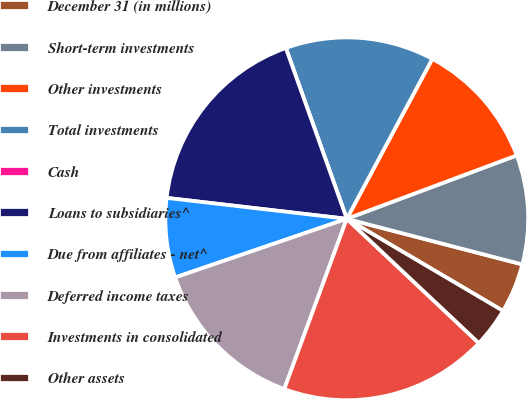Convert chart to OTSL. <chart><loc_0><loc_0><loc_500><loc_500><pie_chart><fcel>December 31 (in millions)<fcel>Short-term investments<fcel>Other investments<fcel>Total investments<fcel>Cash<fcel>Loans to subsidiaries^<fcel>Due from affiliates - net^<fcel>Deferred income taxes<fcel>Investments in consolidated<fcel>Other assets<nl><fcel>4.43%<fcel>9.73%<fcel>11.5%<fcel>13.27%<fcel>0.0%<fcel>17.7%<fcel>7.08%<fcel>14.16%<fcel>18.58%<fcel>3.54%<nl></chart> 